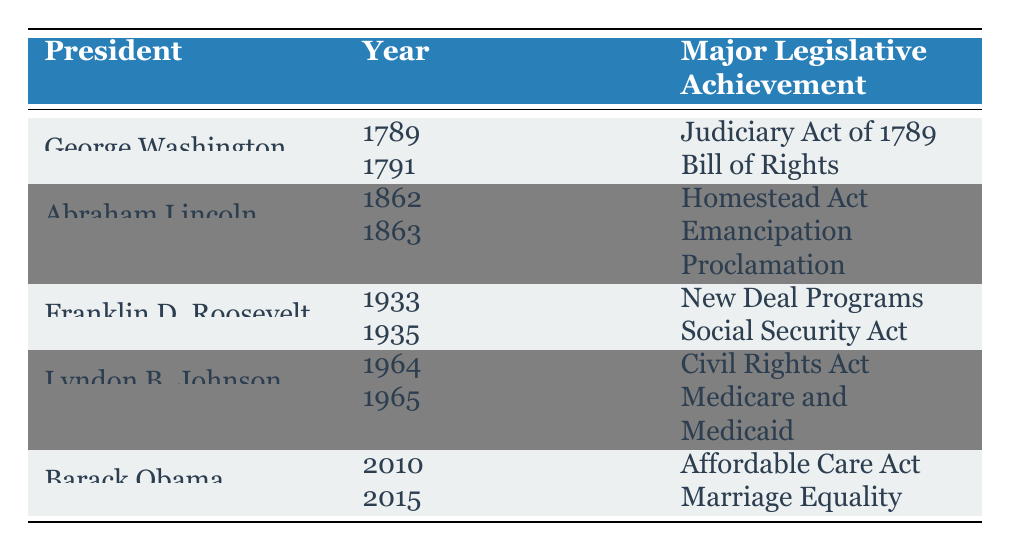What major legislative achievement did George Washington accomplish in 1789? According to the table, George Washington's achievement in 1789 is the "Judiciary Act of 1789," which established the federal judiciary of the United States.
Answer: Judiciary Act of 1789 Which president is associated with the "Civil Rights Act"? The table indicates that the "Civil Rights Act" is a major legislative achievement of Lyndon B. Johnson in 1964.
Answer: Lyndon B. Johnson How many major legislative achievements did Abraham Lincoln have? The table shows that Abraham Lincoln has a total of 2 major legislative achievements: the "Homestead Act" and the "Emancipation Proclamation."
Answer: 2 Which legislative achievement occurred most recently according to the table? The most recent achievement listed in the table is the "Marriage Equality," associated with Barack Obama in 2015.
Answer: Marriage Equality Did Franklin D. Roosevelt establish the Social Security Act? Yes, the table confirms that Franklin D. Roosevelt achieved this in 1935, as it is noted in the list of his major legislative achievements.
Answer: Yes In what year did Lyndon B. Johnson enact Medicare and Medicaid, and what are they? The table shows that Lyndon B. Johnson enacted Medicare and Medicaid in 1965. Medicare is for the elderly, and Medicaid is for the poor.
Answer: 1965; Medicare and Medicaid What is the difference in years between the Judiciary Act of 1789 and the Bill of Rights? The Judiciary Act was established in 1789 and the Bill of Rights in 1791. The difference is 1791 - 1789 = 2 years.
Answer: 2 years Which president had a legislative achievement that specifically aimed at economic recovery during the Great Depression? Franklin D. Roosevelt had the "New Deal Programs" aimed at economic recovery during the Great Depression in 1933, as listed in the table.
Answer: Franklin D. Roosevelt True or False: Barack Obama was responsible for the establishment of the Homestead Act. The table indicates that the Homestead Act was an achievement of Abraham Lincoln, not Barack Obama, making this statement false.
Answer: False If you combine the years of achievements for Franklin D. Roosevelt and Lyndon B. Johnson, what is the total? Franklin D. Roosevelt's achievements are from 1933 and 1935, while Lyndon B. Johnson's are from 1964 and 1965. Adding these together gives 1933 + 1935 + 1964 + 1965 = 7807.
Answer: 7807 